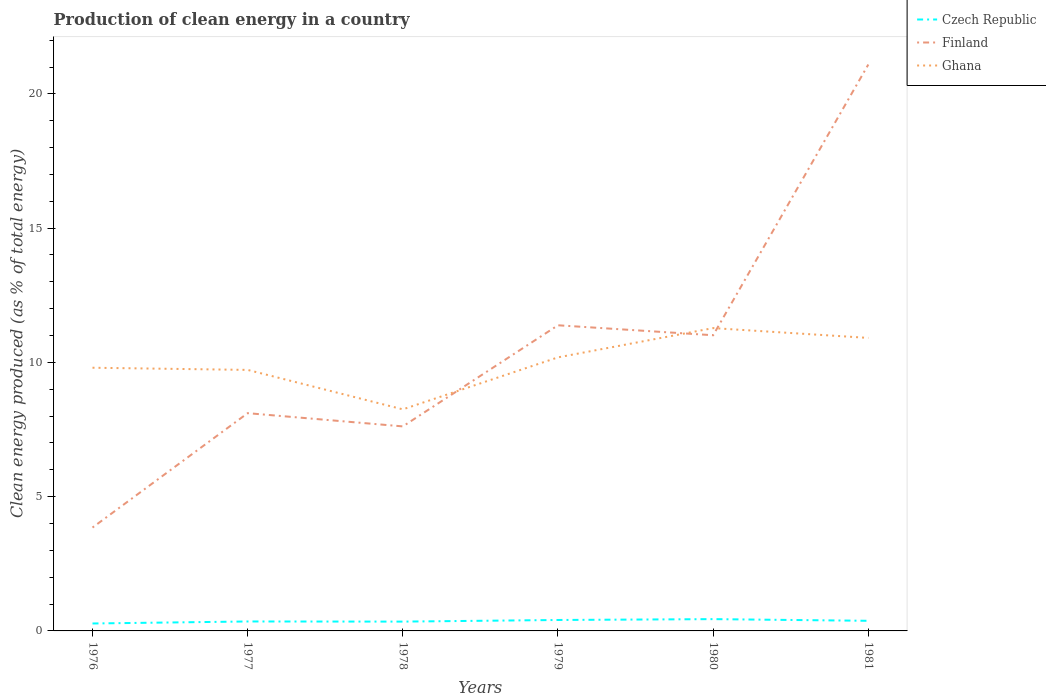How many different coloured lines are there?
Provide a short and direct response. 3. Across all years, what is the maximum percentage of clean energy produced in Finland?
Provide a short and direct response. 3.85. In which year was the percentage of clean energy produced in Ghana maximum?
Your answer should be compact. 1978. What is the total percentage of clean energy produced in Finland in the graph?
Make the answer very short. -2.9. What is the difference between the highest and the second highest percentage of clean energy produced in Finland?
Provide a succinct answer. 17.24. Is the percentage of clean energy produced in Finland strictly greater than the percentage of clean energy produced in Ghana over the years?
Make the answer very short. No. How many years are there in the graph?
Provide a short and direct response. 6. Does the graph contain grids?
Provide a short and direct response. No. Where does the legend appear in the graph?
Provide a succinct answer. Top right. What is the title of the graph?
Provide a short and direct response. Production of clean energy in a country. What is the label or title of the Y-axis?
Ensure brevity in your answer.  Clean energy produced (as % of total energy). What is the Clean energy produced (as % of total energy) in Czech Republic in 1976?
Ensure brevity in your answer.  0.28. What is the Clean energy produced (as % of total energy) of Finland in 1976?
Give a very brief answer. 3.85. What is the Clean energy produced (as % of total energy) in Ghana in 1976?
Your response must be concise. 9.8. What is the Clean energy produced (as % of total energy) in Czech Republic in 1977?
Keep it short and to the point. 0.35. What is the Clean energy produced (as % of total energy) of Finland in 1977?
Make the answer very short. 8.11. What is the Clean energy produced (as % of total energy) of Ghana in 1977?
Ensure brevity in your answer.  9.72. What is the Clean energy produced (as % of total energy) of Czech Republic in 1978?
Your answer should be compact. 0.35. What is the Clean energy produced (as % of total energy) of Finland in 1978?
Provide a succinct answer. 7.62. What is the Clean energy produced (as % of total energy) of Ghana in 1978?
Provide a succinct answer. 8.25. What is the Clean energy produced (as % of total energy) of Czech Republic in 1979?
Your answer should be compact. 0.41. What is the Clean energy produced (as % of total energy) in Finland in 1979?
Your answer should be very brief. 11.38. What is the Clean energy produced (as % of total energy) in Ghana in 1979?
Your response must be concise. 10.19. What is the Clean energy produced (as % of total energy) of Czech Republic in 1980?
Provide a succinct answer. 0.44. What is the Clean energy produced (as % of total energy) of Finland in 1980?
Your response must be concise. 11.01. What is the Clean energy produced (as % of total energy) of Ghana in 1980?
Give a very brief answer. 11.28. What is the Clean energy produced (as % of total energy) of Czech Republic in 1981?
Keep it short and to the point. 0.38. What is the Clean energy produced (as % of total energy) in Finland in 1981?
Keep it short and to the point. 21.09. What is the Clean energy produced (as % of total energy) in Ghana in 1981?
Give a very brief answer. 10.91. Across all years, what is the maximum Clean energy produced (as % of total energy) in Czech Republic?
Offer a very short reply. 0.44. Across all years, what is the maximum Clean energy produced (as % of total energy) of Finland?
Your response must be concise. 21.09. Across all years, what is the maximum Clean energy produced (as % of total energy) in Ghana?
Your response must be concise. 11.28. Across all years, what is the minimum Clean energy produced (as % of total energy) of Czech Republic?
Give a very brief answer. 0.28. Across all years, what is the minimum Clean energy produced (as % of total energy) of Finland?
Give a very brief answer. 3.85. Across all years, what is the minimum Clean energy produced (as % of total energy) of Ghana?
Your answer should be compact. 8.25. What is the total Clean energy produced (as % of total energy) in Czech Republic in the graph?
Ensure brevity in your answer.  2.2. What is the total Clean energy produced (as % of total energy) of Finland in the graph?
Your answer should be compact. 63.06. What is the total Clean energy produced (as % of total energy) in Ghana in the graph?
Your answer should be compact. 60.15. What is the difference between the Clean energy produced (as % of total energy) in Czech Republic in 1976 and that in 1977?
Make the answer very short. -0.08. What is the difference between the Clean energy produced (as % of total energy) in Finland in 1976 and that in 1977?
Make the answer very short. -4.26. What is the difference between the Clean energy produced (as % of total energy) in Ghana in 1976 and that in 1977?
Your response must be concise. 0.08. What is the difference between the Clean energy produced (as % of total energy) of Czech Republic in 1976 and that in 1978?
Your answer should be very brief. -0.07. What is the difference between the Clean energy produced (as % of total energy) of Finland in 1976 and that in 1978?
Give a very brief answer. -3.77. What is the difference between the Clean energy produced (as % of total energy) in Ghana in 1976 and that in 1978?
Make the answer very short. 1.55. What is the difference between the Clean energy produced (as % of total energy) in Czech Republic in 1976 and that in 1979?
Provide a short and direct response. -0.13. What is the difference between the Clean energy produced (as % of total energy) in Finland in 1976 and that in 1979?
Make the answer very short. -7.53. What is the difference between the Clean energy produced (as % of total energy) of Ghana in 1976 and that in 1979?
Your answer should be compact. -0.39. What is the difference between the Clean energy produced (as % of total energy) in Czech Republic in 1976 and that in 1980?
Your answer should be very brief. -0.16. What is the difference between the Clean energy produced (as % of total energy) of Finland in 1976 and that in 1980?
Provide a succinct answer. -7.16. What is the difference between the Clean energy produced (as % of total energy) of Ghana in 1976 and that in 1980?
Provide a short and direct response. -1.48. What is the difference between the Clean energy produced (as % of total energy) in Finland in 1976 and that in 1981?
Make the answer very short. -17.24. What is the difference between the Clean energy produced (as % of total energy) in Ghana in 1976 and that in 1981?
Give a very brief answer. -1.11. What is the difference between the Clean energy produced (as % of total energy) of Czech Republic in 1977 and that in 1978?
Make the answer very short. 0.01. What is the difference between the Clean energy produced (as % of total energy) in Finland in 1977 and that in 1978?
Offer a very short reply. 0.49. What is the difference between the Clean energy produced (as % of total energy) of Ghana in 1977 and that in 1978?
Make the answer very short. 1.47. What is the difference between the Clean energy produced (as % of total energy) in Czech Republic in 1977 and that in 1979?
Give a very brief answer. -0.06. What is the difference between the Clean energy produced (as % of total energy) of Finland in 1977 and that in 1979?
Ensure brevity in your answer.  -3.27. What is the difference between the Clean energy produced (as % of total energy) in Ghana in 1977 and that in 1979?
Make the answer very short. -0.47. What is the difference between the Clean energy produced (as % of total energy) of Czech Republic in 1977 and that in 1980?
Make the answer very short. -0.09. What is the difference between the Clean energy produced (as % of total energy) in Finland in 1977 and that in 1980?
Your response must be concise. -2.9. What is the difference between the Clean energy produced (as % of total energy) of Ghana in 1977 and that in 1980?
Ensure brevity in your answer.  -1.56. What is the difference between the Clean energy produced (as % of total energy) of Czech Republic in 1977 and that in 1981?
Make the answer very short. -0.02. What is the difference between the Clean energy produced (as % of total energy) of Finland in 1977 and that in 1981?
Provide a succinct answer. -12.98. What is the difference between the Clean energy produced (as % of total energy) of Ghana in 1977 and that in 1981?
Provide a short and direct response. -1.19. What is the difference between the Clean energy produced (as % of total energy) in Czech Republic in 1978 and that in 1979?
Your answer should be compact. -0.06. What is the difference between the Clean energy produced (as % of total energy) in Finland in 1978 and that in 1979?
Ensure brevity in your answer.  -3.77. What is the difference between the Clean energy produced (as % of total energy) in Ghana in 1978 and that in 1979?
Provide a short and direct response. -1.94. What is the difference between the Clean energy produced (as % of total energy) of Czech Republic in 1978 and that in 1980?
Offer a terse response. -0.09. What is the difference between the Clean energy produced (as % of total energy) in Finland in 1978 and that in 1980?
Offer a very short reply. -3.39. What is the difference between the Clean energy produced (as % of total energy) of Ghana in 1978 and that in 1980?
Your answer should be compact. -3.03. What is the difference between the Clean energy produced (as % of total energy) in Czech Republic in 1978 and that in 1981?
Offer a terse response. -0.03. What is the difference between the Clean energy produced (as % of total energy) of Finland in 1978 and that in 1981?
Make the answer very short. -13.48. What is the difference between the Clean energy produced (as % of total energy) of Ghana in 1978 and that in 1981?
Your response must be concise. -2.66. What is the difference between the Clean energy produced (as % of total energy) in Czech Republic in 1979 and that in 1980?
Your answer should be compact. -0.03. What is the difference between the Clean energy produced (as % of total energy) of Finland in 1979 and that in 1980?
Provide a short and direct response. 0.37. What is the difference between the Clean energy produced (as % of total energy) in Ghana in 1979 and that in 1980?
Provide a succinct answer. -1.09. What is the difference between the Clean energy produced (as % of total energy) of Czech Republic in 1979 and that in 1981?
Make the answer very short. 0.03. What is the difference between the Clean energy produced (as % of total energy) of Finland in 1979 and that in 1981?
Offer a very short reply. -9.71. What is the difference between the Clean energy produced (as % of total energy) of Ghana in 1979 and that in 1981?
Your answer should be very brief. -0.72. What is the difference between the Clean energy produced (as % of total energy) in Czech Republic in 1980 and that in 1981?
Keep it short and to the point. 0.06. What is the difference between the Clean energy produced (as % of total energy) in Finland in 1980 and that in 1981?
Ensure brevity in your answer.  -10.08. What is the difference between the Clean energy produced (as % of total energy) in Ghana in 1980 and that in 1981?
Provide a short and direct response. 0.37. What is the difference between the Clean energy produced (as % of total energy) in Czech Republic in 1976 and the Clean energy produced (as % of total energy) in Finland in 1977?
Keep it short and to the point. -7.83. What is the difference between the Clean energy produced (as % of total energy) in Czech Republic in 1976 and the Clean energy produced (as % of total energy) in Ghana in 1977?
Ensure brevity in your answer.  -9.44. What is the difference between the Clean energy produced (as % of total energy) in Finland in 1976 and the Clean energy produced (as % of total energy) in Ghana in 1977?
Ensure brevity in your answer.  -5.87. What is the difference between the Clean energy produced (as % of total energy) in Czech Republic in 1976 and the Clean energy produced (as % of total energy) in Finland in 1978?
Provide a succinct answer. -7.34. What is the difference between the Clean energy produced (as % of total energy) of Czech Republic in 1976 and the Clean energy produced (as % of total energy) of Ghana in 1978?
Provide a short and direct response. -7.97. What is the difference between the Clean energy produced (as % of total energy) of Finland in 1976 and the Clean energy produced (as % of total energy) of Ghana in 1978?
Give a very brief answer. -4.4. What is the difference between the Clean energy produced (as % of total energy) in Czech Republic in 1976 and the Clean energy produced (as % of total energy) in Finland in 1979?
Provide a short and direct response. -11.11. What is the difference between the Clean energy produced (as % of total energy) in Czech Republic in 1976 and the Clean energy produced (as % of total energy) in Ghana in 1979?
Your response must be concise. -9.91. What is the difference between the Clean energy produced (as % of total energy) in Finland in 1976 and the Clean energy produced (as % of total energy) in Ghana in 1979?
Make the answer very short. -6.34. What is the difference between the Clean energy produced (as % of total energy) in Czech Republic in 1976 and the Clean energy produced (as % of total energy) in Finland in 1980?
Offer a terse response. -10.73. What is the difference between the Clean energy produced (as % of total energy) in Czech Republic in 1976 and the Clean energy produced (as % of total energy) in Ghana in 1980?
Offer a very short reply. -11. What is the difference between the Clean energy produced (as % of total energy) of Finland in 1976 and the Clean energy produced (as % of total energy) of Ghana in 1980?
Your response must be concise. -7.43. What is the difference between the Clean energy produced (as % of total energy) in Czech Republic in 1976 and the Clean energy produced (as % of total energy) in Finland in 1981?
Provide a short and direct response. -20.82. What is the difference between the Clean energy produced (as % of total energy) in Czech Republic in 1976 and the Clean energy produced (as % of total energy) in Ghana in 1981?
Make the answer very short. -10.63. What is the difference between the Clean energy produced (as % of total energy) in Finland in 1976 and the Clean energy produced (as % of total energy) in Ghana in 1981?
Provide a short and direct response. -7.06. What is the difference between the Clean energy produced (as % of total energy) in Czech Republic in 1977 and the Clean energy produced (as % of total energy) in Finland in 1978?
Offer a very short reply. -7.26. What is the difference between the Clean energy produced (as % of total energy) in Czech Republic in 1977 and the Clean energy produced (as % of total energy) in Ghana in 1978?
Ensure brevity in your answer.  -7.9. What is the difference between the Clean energy produced (as % of total energy) of Finland in 1977 and the Clean energy produced (as % of total energy) of Ghana in 1978?
Offer a very short reply. -0.14. What is the difference between the Clean energy produced (as % of total energy) in Czech Republic in 1977 and the Clean energy produced (as % of total energy) in Finland in 1979?
Ensure brevity in your answer.  -11.03. What is the difference between the Clean energy produced (as % of total energy) in Czech Republic in 1977 and the Clean energy produced (as % of total energy) in Ghana in 1979?
Make the answer very short. -9.84. What is the difference between the Clean energy produced (as % of total energy) in Finland in 1977 and the Clean energy produced (as % of total energy) in Ghana in 1979?
Your answer should be compact. -2.08. What is the difference between the Clean energy produced (as % of total energy) in Czech Republic in 1977 and the Clean energy produced (as % of total energy) in Finland in 1980?
Provide a succinct answer. -10.66. What is the difference between the Clean energy produced (as % of total energy) in Czech Republic in 1977 and the Clean energy produced (as % of total energy) in Ghana in 1980?
Ensure brevity in your answer.  -10.93. What is the difference between the Clean energy produced (as % of total energy) in Finland in 1977 and the Clean energy produced (as % of total energy) in Ghana in 1980?
Keep it short and to the point. -3.17. What is the difference between the Clean energy produced (as % of total energy) in Czech Republic in 1977 and the Clean energy produced (as % of total energy) in Finland in 1981?
Provide a short and direct response. -20.74. What is the difference between the Clean energy produced (as % of total energy) in Czech Republic in 1977 and the Clean energy produced (as % of total energy) in Ghana in 1981?
Provide a short and direct response. -10.56. What is the difference between the Clean energy produced (as % of total energy) in Finland in 1977 and the Clean energy produced (as % of total energy) in Ghana in 1981?
Keep it short and to the point. -2.8. What is the difference between the Clean energy produced (as % of total energy) of Czech Republic in 1978 and the Clean energy produced (as % of total energy) of Finland in 1979?
Give a very brief answer. -11.04. What is the difference between the Clean energy produced (as % of total energy) in Czech Republic in 1978 and the Clean energy produced (as % of total energy) in Ghana in 1979?
Your answer should be compact. -9.84. What is the difference between the Clean energy produced (as % of total energy) of Finland in 1978 and the Clean energy produced (as % of total energy) of Ghana in 1979?
Give a very brief answer. -2.57. What is the difference between the Clean energy produced (as % of total energy) of Czech Republic in 1978 and the Clean energy produced (as % of total energy) of Finland in 1980?
Offer a very short reply. -10.66. What is the difference between the Clean energy produced (as % of total energy) of Czech Republic in 1978 and the Clean energy produced (as % of total energy) of Ghana in 1980?
Keep it short and to the point. -10.93. What is the difference between the Clean energy produced (as % of total energy) in Finland in 1978 and the Clean energy produced (as % of total energy) in Ghana in 1980?
Your answer should be compact. -3.66. What is the difference between the Clean energy produced (as % of total energy) in Czech Republic in 1978 and the Clean energy produced (as % of total energy) in Finland in 1981?
Ensure brevity in your answer.  -20.75. What is the difference between the Clean energy produced (as % of total energy) in Czech Republic in 1978 and the Clean energy produced (as % of total energy) in Ghana in 1981?
Give a very brief answer. -10.56. What is the difference between the Clean energy produced (as % of total energy) of Finland in 1978 and the Clean energy produced (as % of total energy) of Ghana in 1981?
Provide a succinct answer. -3.3. What is the difference between the Clean energy produced (as % of total energy) in Czech Republic in 1979 and the Clean energy produced (as % of total energy) in Finland in 1980?
Your response must be concise. -10.6. What is the difference between the Clean energy produced (as % of total energy) in Czech Republic in 1979 and the Clean energy produced (as % of total energy) in Ghana in 1980?
Provide a short and direct response. -10.87. What is the difference between the Clean energy produced (as % of total energy) in Finland in 1979 and the Clean energy produced (as % of total energy) in Ghana in 1980?
Offer a very short reply. 0.1. What is the difference between the Clean energy produced (as % of total energy) of Czech Republic in 1979 and the Clean energy produced (as % of total energy) of Finland in 1981?
Your answer should be compact. -20.69. What is the difference between the Clean energy produced (as % of total energy) of Czech Republic in 1979 and the Clean energy produced (as % of total energy) of Ghana in 1981?
Your response must be concise. -10.5. What is the difference between the Clean energy produced (as % of total energy) of Finland in 1979 and the Clean energy produced (as % of total energy) of Ghana in 1981?
Provide a short and direct response. 0.47. What is the difference between the Clean energy produced (as % of total energy) in Czech Republic in 1980 and the Clean energy produced (as % of total energy) in Finland in 1981?
Offer a terse response. -20.65. What is the difference between the Clean energy produced (as % of total energy) of Czech Republic in 1980 and the Clean energy produced (as % of total energy) of Ghana in 1981?
Ensure brevity in your answer.  -10.47. What is the difference between the Clean energy produced (as % of total energy) of Finland in 1980 and the Clean energy produced (as % of total energy) of Ghana in 1981?
Offer a terse response. 0.1. What is the average Clean energy produced (as % of total energy) of Czech Republic per year?
Keep it short and to the point. 0.37. What is the average Clean energy produced (as % of total energy) of Finland per year?
Your answer should be very brief. 10.51. What is the average Clean energy produced (as % of total energy) of Ghana per year?
Keep it short and to the point. 10.02. In the year 1976, what is the difference between the Clean energy produced (as % of total energy) of Czech Republic and Clean energy produced (as % of total energy) of Finland?
Your answer should be compact. -3.57. In the year 1976, what is the difference between the Clean energy produced (as % of total energy) of Czech Republic and Clean energy produced (as % of total energy) of Ghana?
Make the answer very short. -9.52. In the year 1976, what is the difference between the Clean energy produced (as % of total energy) in Finland and Clean energy produced (as % of total energy) in Ghana?
Offer a terse response. -5.95. In the year 1977, what is the difference between the Clean energy produced (as % of total energy) in Czech Republic and Clean energy produced (as % of total energy) in Finland?
Ensure brevity in your answer.  -7.76. In the year 1977, what is the difference between the Clean energy produced (as % of total energy) of Czech Republic and Clean energy produced (as % of total energy) of Ghana?
Make the answer very short. -9.37. In the year 1977, what is the difference between the Clean energy produced (as % of total energy) of Finland and Clean energy produced (as % of total energy) of Ghana?
Offer a terse response. -1.61. In the year 1978, what is the difference between the Clean energy produced (as % of total energy) of Czech Republic and Clean energy produced (as % of total energy) of Finland?
Offer a terse response. -7.27. In the year 1978, what is the difference between the Clean energy produced (as % of total energy) in Czech Republic and Clean energy produced (as % of total energy) in Ghana?
Your response must be concise. -7.9. In the year 1978, what is the difference between the Clean energy produced (as % of total energy) in Finland and Clean energy produced (as % of total energy) in Ghana?
Your response must be concise. -0.63. In the year 1979, what is the difference between the Clean energy produced (as % of total energy) of Czech Republic and Clean energy produced (as % of total energy) of Finland?
Your answer should be compact. -10.97. In the year 1979, what is the difference between the Clean energy produced (as % of total energy) of Czech Republic and Clean energy produced (as % of total energy) of Ghana?
Make the answer very short. -9.78. In the year 1979, what is the difference between the Clean energy produced (as % of total energy) in Finland and Clean energy produced (as % of total energy) in Ghana?
Ensure brevity in your answer.  1.19. In the year 1980, what is the difference between the Clean energy produced (as % of total energy) of Czech Republic and Clean energy produced (as % of total energy) of Finland?
Your response must be concise. -10.57. In the year 1980, what is the difference between the Clean energy produced (as % of total energy) of Czech Republic and Clean energy produced (as % of total energy) of Ghana?
Your answer should be very brief. -10.84. In the year 1980, what is the difference between the Clean energy produced (as % of total energy) of Finland and Clean energy produced (as % of total energy) of Ghana?
Your answer should be very brief. -0.27. In the year 1981, what is the difference between the Clean energy produced (as % of total energy) in Czech Republic and Clean energy produced (as % of total energy) in Finland?
Offer a very short reply. -20.72. In the year 1981, what is the difference between the Clean energy produced (as % of total energy) of Czech Republic and Clean energy produced (as % of total energy) of Ghana?
Offer a very short reply. -10.54. In the year 1981, what is the difference between the Clean energy produced (as % of total energy) of Finland and Clean energy produced (as % of total energy) of Ghana?
Your answer should be very brief. 10.18. What is the ratio of the Clean energy produced (as % of total energy) of Czech Republic in 1976 to that in 1977?
Ensure brevity in your answer.  0.79. What is the ratio of the Clean energy produced (as % of total energy) in Finland in 1976 to that in 1977?
Keep it short and to the point. 0.47. What is the ratio of the Clean energy produced (as % of total energy) in Ghana in 1976 to that in 1977?
Your answer should be compact. 1.01. What is the ratio of the Clean energy produced (as % of total energy) in Czech Republic in 1976 to that in 1978?
Offer a terse response. 0.8. What is the ratio of the Clean energy produced (as % of total energy) of Finland in 1976 to that in 1978?
Give a very brief answer. 0.51. What is the ratio of the Clean energy produced (as % of total energy) in Ghana in 1976 to that in 1978?
Provide a succinct answer. 1.19. What is the ratio of the Clean energy produced (as % of total energy) of Czech Republic in 1976 to that in 1979?
Your answer should be very brief. 0.68. What is the ratio of the Clean energy produced (as % of total energy) in Finland in 1976 to that in 1979?
Offer a very short reply. 0.34. What is the ratio of the Clean energy produced (as % of total energy) of Ghana in 1976 to that in 1979?
Keep it short and to the point. 0.96. What is the ratio of the Clean energy produced (as % of total energy) of Czech Republic in 1976 to that in 1980?
Provide a short and direct response. 0.63. What is the ratio of the Clean energy produced (as % of total energy) of Finland in 1976 to that in 1980?
Make the answer very short. 0.35. What is the ratio of the Clean energy produced (as % of total energy) of Ghana in 1976 to that in 1980?
Your response must be concise. 0.87. What is the ratio of the Clean energy produced (as % of total energy) in Czech Republic in 1976 to that in 1981?
Your answer should be compact. 0.73. What is the ratio of the Clean energy produced (as % of total energy) of Finland in 1976 to that in 1981?
Offer a very short reply. 0.18. What is the ratio of the Clean energy produced (as % of total energy) of Ghana in 1976 to that in 1981?
Provide a short and direct response. 0.9. What is the ratio of the Clean energy produced (as % of total energy) of Finland in 1977 to that in 1978?
Provide a succinct answer. 1.06. What is the ratio of the Clean energy produced (as % of total energy) in Ghana in 1977 to that in 1978?
Ensure brevity in your answer.  1.18. What is the ratio of the Clean energy produced (as % of total energy) of Czech Republic in 1977 to that in 1979?
Keep it short and to the point. 0.86. What is the ratio of the Clean energy produced (as % of total energy) of Finland in 1977 to that in 1979?
Provide a succinct answer. 0.71. What is the ratio of the Clean energy produced (as % of total energy) in Ghana in 1977 to that in 1979?
Offer a very short reply. 0.95. What is the ratio of the Clean energy produced (as % of total energy) of Czech Republic in 1977 to that in 1980?
Give a very brief answer. 0.8. What is the ratio of the Clean energy produced (as % of total energy) in Finland in 1977 to that in 1980?
Make the answer very short. 0.74. What is the ratio of the Clean energy produced (as % of total energy) in Ghana in 1977 to that in 1980?
Provide a succinct answer. 0.86. What is the ratio of the Clean energy produced (as % of total energy) of Czech Republic in 1977 to that in 1981?
Offer a very short reply. 0.93. What is the ratio of the Clean energy produced (as % of total energy) of Finland in 1977 to that in 1981?
Your answer should be very brief. 0.38. What is the ratio of the Clean energy produced (as % of total energy) in Ghana in 1977 to that in 1981?
Keep it short and to the point. 0.89. What is the ratio of the Clean energy produced (as % of total energy) of Czech Republic in 1978 to that in 1979?
Your response must be concise. 0.85. What is the ratio of the Clean energy produced (as % of total energy) in Finland in 1978 to that in 1979?
Ensure brevity in your answer.  0.67. What is the ratio of the Clean energy produced (as % of total energy) in Ghana in 1978 to that in 1979?
Provide a short and direct response. 0.81. What is the ratio of the Clean energy produced (as % of total energy) of Czech Republic in 1978 to that in 1980?
Ensure brevity in your answer.  0.79. What is the ratio of the Clean energy produced (as % of total energy) in Finland in 1978 to that in 1980?
Your response must be concise. 0.69. What is the ratio of the Clean energy produced (as % of total energy) in Ghana in 1978 to that in 1980?
Keep it short and to the point. 0.73. What is the ratio of the Clean energy produced (as % of total energy) of Czech Republic in 1978 to that in 1981?
Your answer should be very brief. 0.92. What is the ratio of the Clean energy produced (as % of total energy) in Finland in 1978 to that in 1981?
Ensure brevity in your answer.  0.36. What is the ratio of the Clean energy produced (as % of total energy) of Ghana in 1978 to that in 1981?
Provide a succinct answer. 0.76. What is the ratio of the Clean energy produced (as % of total energy) of Czech Republic in 1979 to that in 1980?
Your response must be concise. 0.93. What is the ratio of the Clean energy produced (as % of total energy) of Finland in 1979 to that in 1980?
Provide a succinct answer. 1.03. What is the ratio of the Clean energy produced (as % of total energy) in Ghana in 1979 to that in 1980?
Ensure brevity in your answer.  0.9. What is the ratio of the Clean energy produced (as % of total energy) in Czech Republic in 1979 to that in 1981?
Give a very brief answer. 1.08. What is the ratio of the Clean energy produced (as % of total energy) of Finland in 1979 to that in 1981?
Keep it short and to the point. 0.54. What is the ratio of the Clean energy produced (as % of total energy) of Ghana in 1979 to that in 1981?
Your response must be concise. 0.93. What is the ratio of the Clean energy produced (as % of total energy) in Czech Republic in 1980 to that in 1981?
Your answer should be compact. 1.17. What is the ratio of the Clean energy produced (as % of total energy) of Finland in 1980 to that in 1981?
Ensure brevity in your answer.  0.52. What is the ratio of the Clean energy produced (as % of total energy) in Ghana in 1980 to that in 1981?
Your answer should be very brief. 1.03. What is the difference between the highest and the second highest Clean energy produced (as % of total energy) of Czech Republic?
Provide a short and direct response. 0.03. What is the difference between the highest and the second highest Clean energy produced (as % of total energy) of Finland?
Give a very brief answer. 9.71. What is the difference between the highest and the second highest Clean energy produced (as % of total energy) in Ghana?
Give a very brief answer. 0.37. What is the difference between the highest and the lowest Clean energy produced (as % of total energy) in Czech Republic?
Offer a terse response. 0.16. What is the difference between the highest and the lowest Clean energy produced (as % of total energy) of Finland?
Give a very brief answer. 17.24. What is the difference between the highest and the lowest Clean energy produced (as % of total energy) in Ghana?
Your response must be concise. 3.03. 